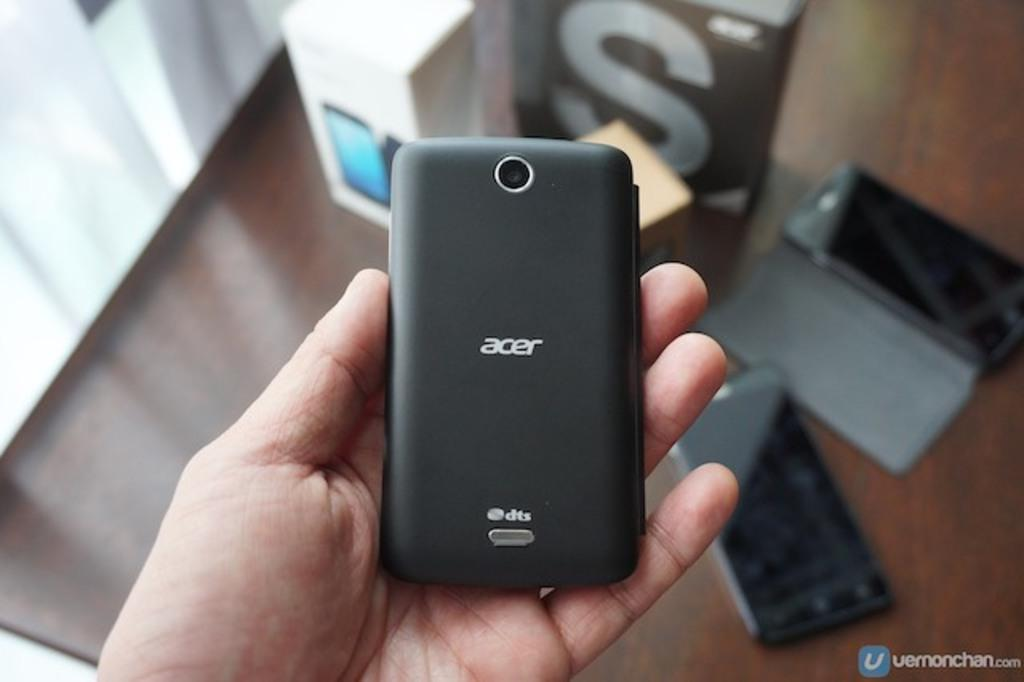<image>
Relay a brief, clear account of the picture shown. A hand holding an Acer phone above a desk. 